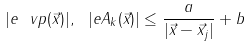Convert formula to latex. <formula><loc_0><loc_0><loc_500><loc_500>| e \ v p ( \vec { x } ) | , \ | e A _ { k } ( \vec { x } ) | \leq \frac { a } { | \vec { x } - \vec { x } _ { j } | } + b</formula> 